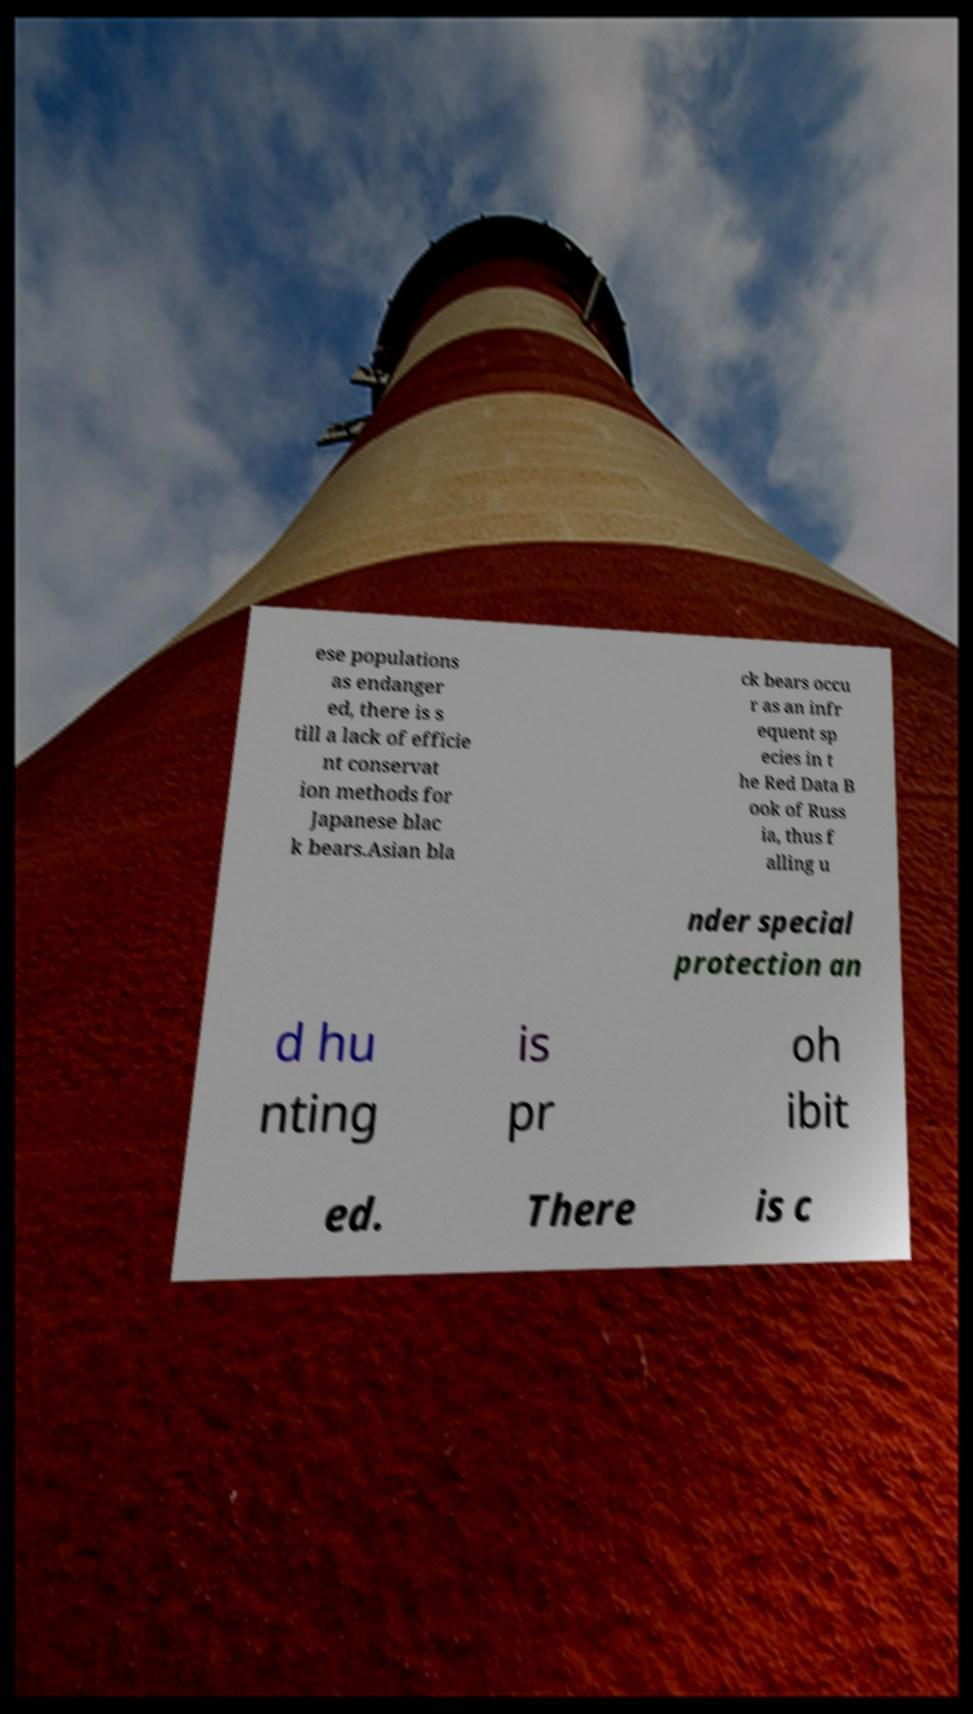For documentation purposes, I need the text within this image transcribed. Could you provide that? ese populations as endanger ed, there is s till a lack of efficie nt conservat ion methods for Japanese blac k bears.Asian bla ck bears occu r as an infr equent sp ecies in t he Red Data B ook of Russ ia, thus f alling u nder special protection an d hu nting is pr oh ibit ed. There is c 